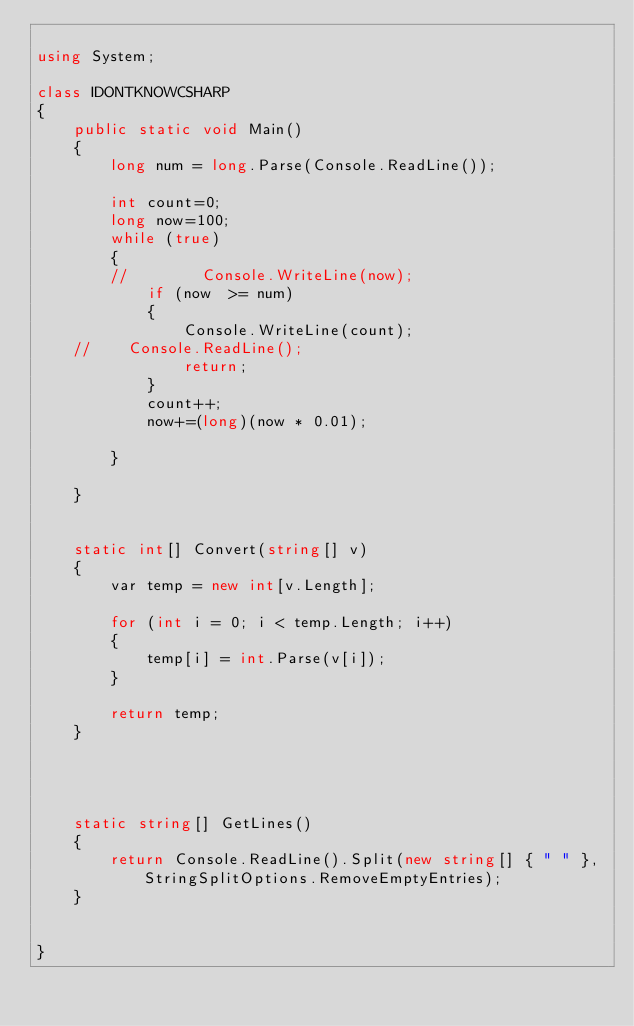Convert code to text. <code><loc_0><loc_0><loc_500><loc_500><_C#_>
using System;

class IDONTKNOWCSHARP
{
    public static void Main()
    {
        long num = long.Parse(Console.ReadLine());

        int count=0;
        long now=100;
        while (true)
        {
        //        Console.WriteLine(now);
            if (now  >= num)
            {
                Console.WriteLine(count);
    //    Console.ReadLine();
                return;
            }
            count++;
            now+=(long)(now * 0.01);

        }

    }


    static int[] Convert(string[] v)
    {
        var temp = new int[v.Length];

        for (int i = 0; i < temp.Length; i++)
        {
            temp[i] = int.Parse(v[i]);
        }

        return temp;
    }




    static string[] GetLines()
    {
        return Console.ReadLine().Split(new string[] { " " }, StringSplitOptions.RemoveEmptyEntries);
    }


}</code> 